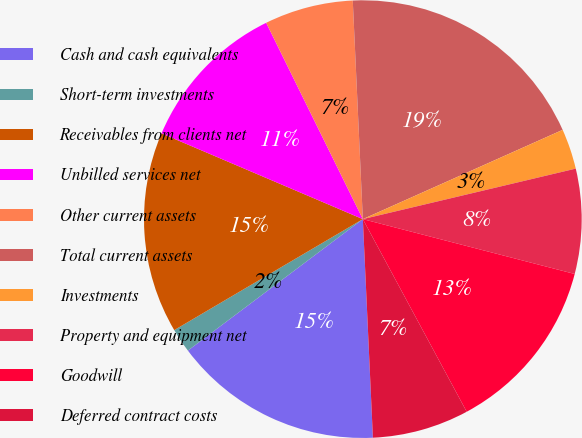Convert chart. <chart><loc_0><loc_0><loc_500><loc_500><pie_chart><fcel>Cash and cash equivalents<fcel>Short-term investments<fcel>Receivables from clients net<fcel>Unbilled services net<fcel>Other current assets<fcel>Total current assets<fcel>Investments<fcel>Property and equipment net<fcel>Goodwill<fcel>Deferred contract costs<nl><fcel>15.48%<fcel>1.79%<fcel>14.88%<fcel>11.31%<fcel>6.55%<fcel>19.05%<fcel>2.98%<fcel>7.74%<fcel>13.1%<fcel>7.14%<nl></chart> 